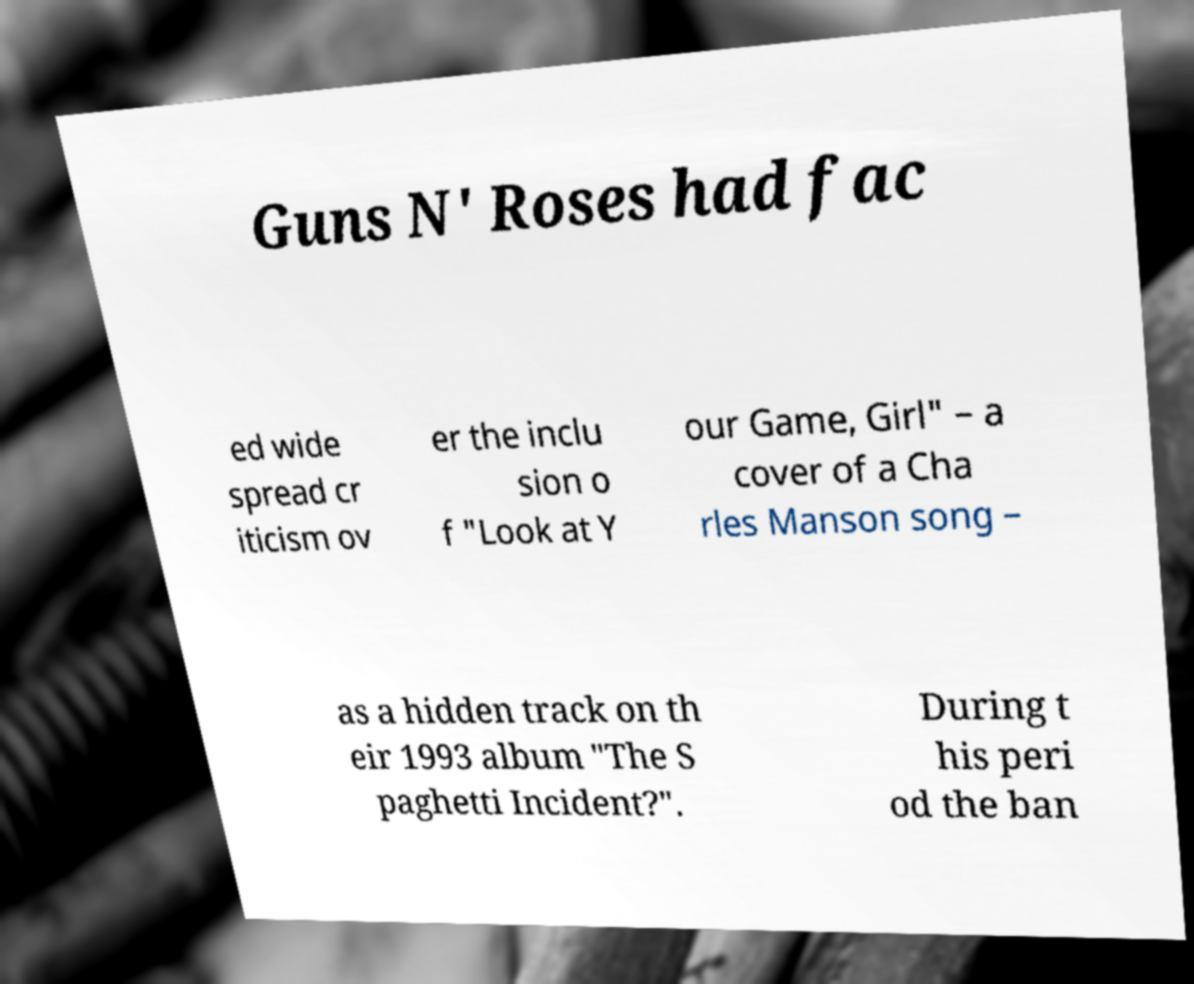What messages or text are displayed in this image? I need them in a readable, typed format. Guns N' Roses had fac ed wide spread cr iticism ov er the inclu sion o f "Look at Y our Game, Girl" – a cover of a Cha rles Manson song – as a hidden track on th eir 1993 album "The S paghetti Incident?". During t his peri od the ban 